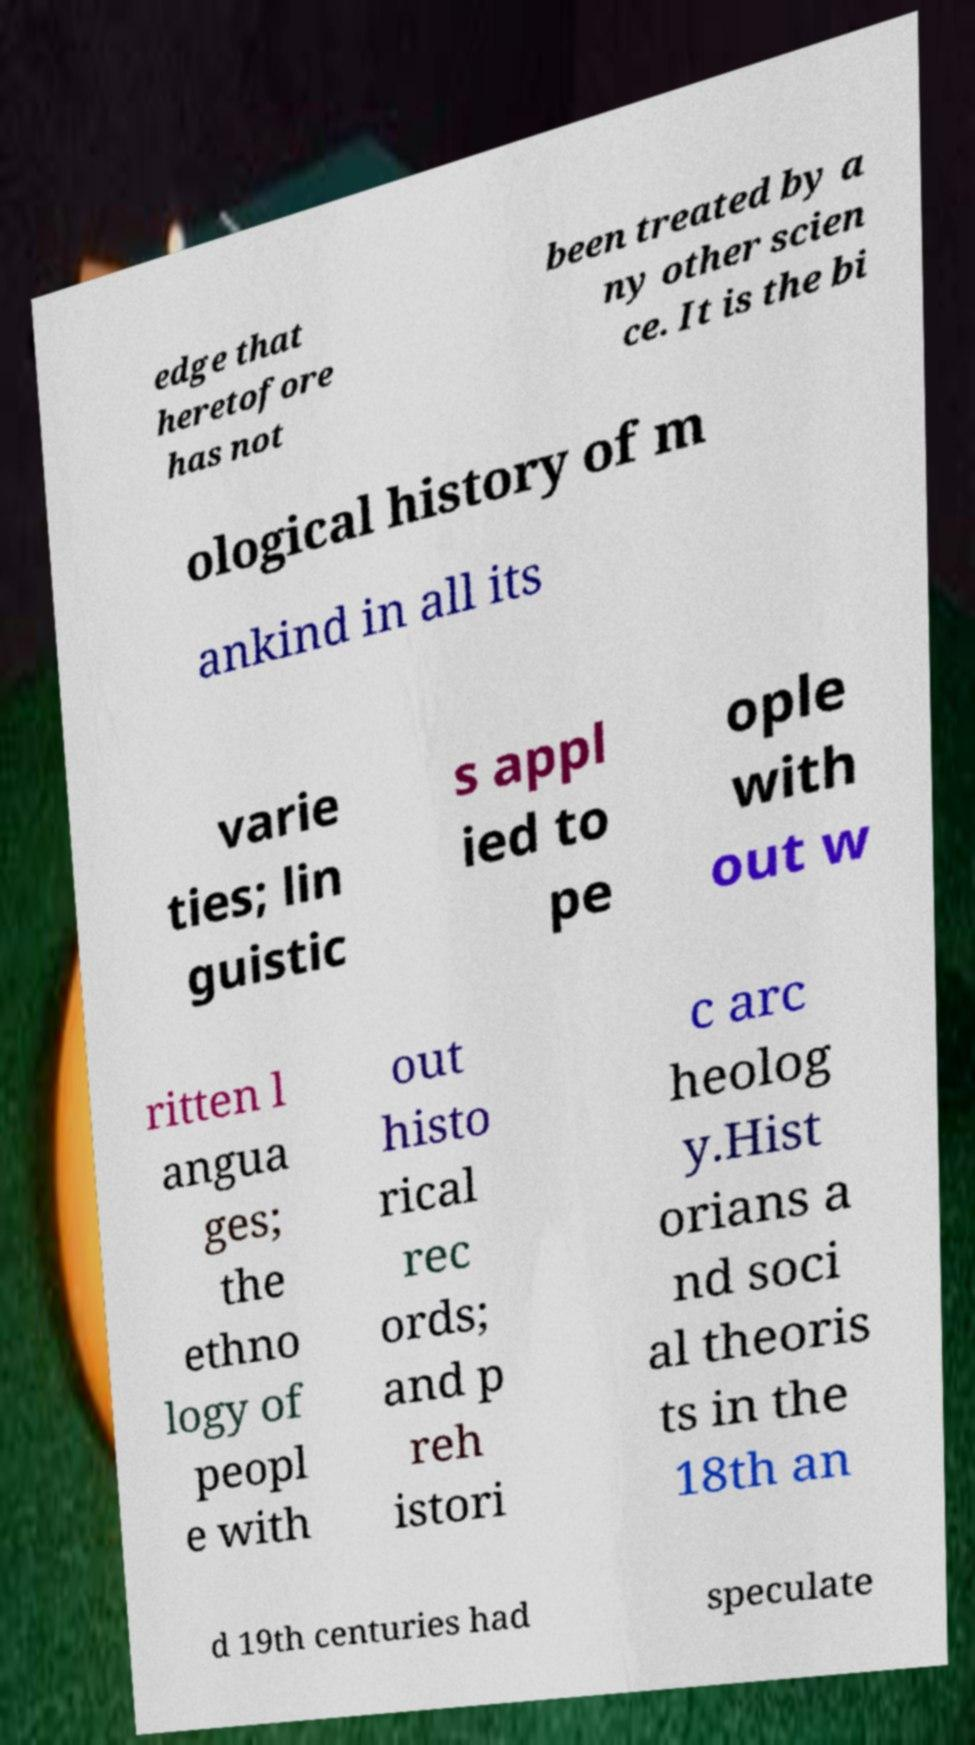Can you read and provide the text displayed in the image?This photo seems to have some interesting text. Can you extract and type it out for me? edge that heretofore has not been treated by a ny other scien ce. It is the bi ological history of m ankind in all its varie ties; lin guistic s appl ied to pe ople with out w ritten l angua ges; the ethno logy of peopl e with out histo rical rec ords; and p reh istori c arc heolog y.Hist orians a nd soci al theoris ts in the 18th an d 19th centuries had speculate 